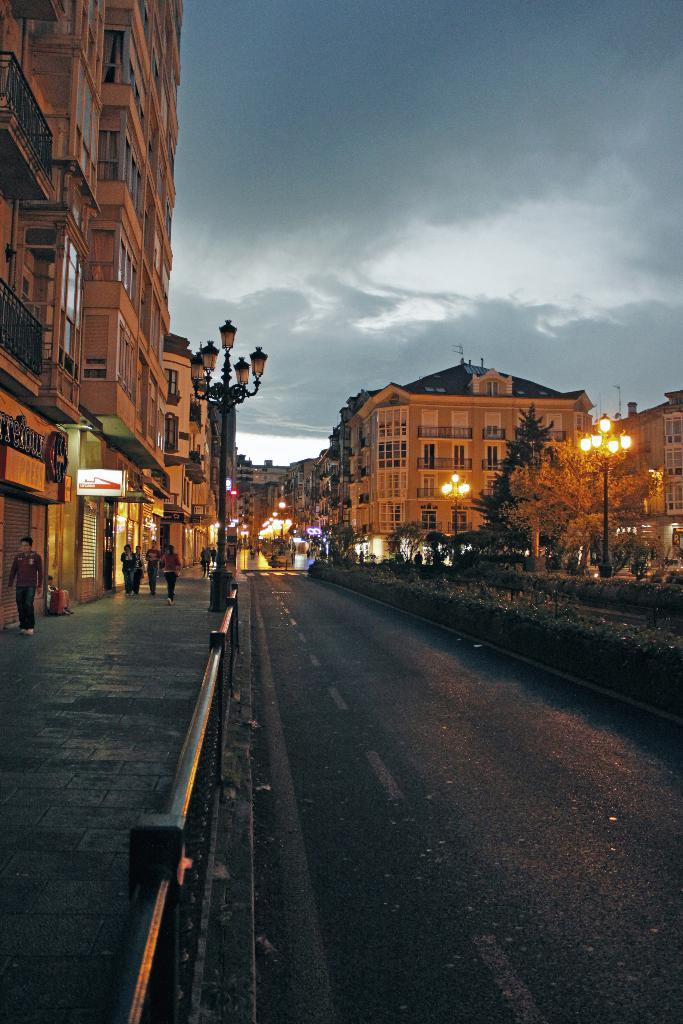What type of pathway is present in the image? There is a road in the image. What structure can be seen alongside the road? There is a fence in the image. What provides illumination in the image? There are light poles in the image. What type of vegetation is present in the image? There are trees in the image. Who can be seen in the image? There are people on the footpath in the image. What type of structures are visible in the image? There are buildings with windows in the image. What else can be seen in the image? There are objects in the image. What is visible in the background of the image? The sky is visible in the background of the image. Where is the shelf located in the image? There is no shelf present in the image. What type of class is being held in the image? There is no class being held in the image. What type of sport is being played in the image? There is no sport, such as volleyball, being played in the image. 